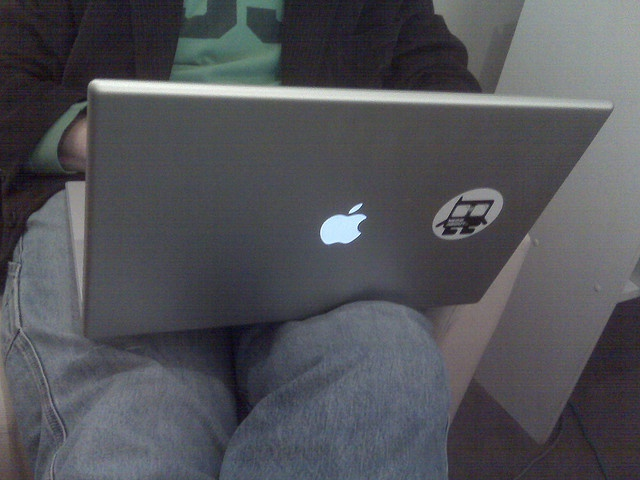Describe the objects in this image and their specific colors. I can see people in purple, gray, and black tones and laptop in purple, gray, black, and darkgray tones in this image. 